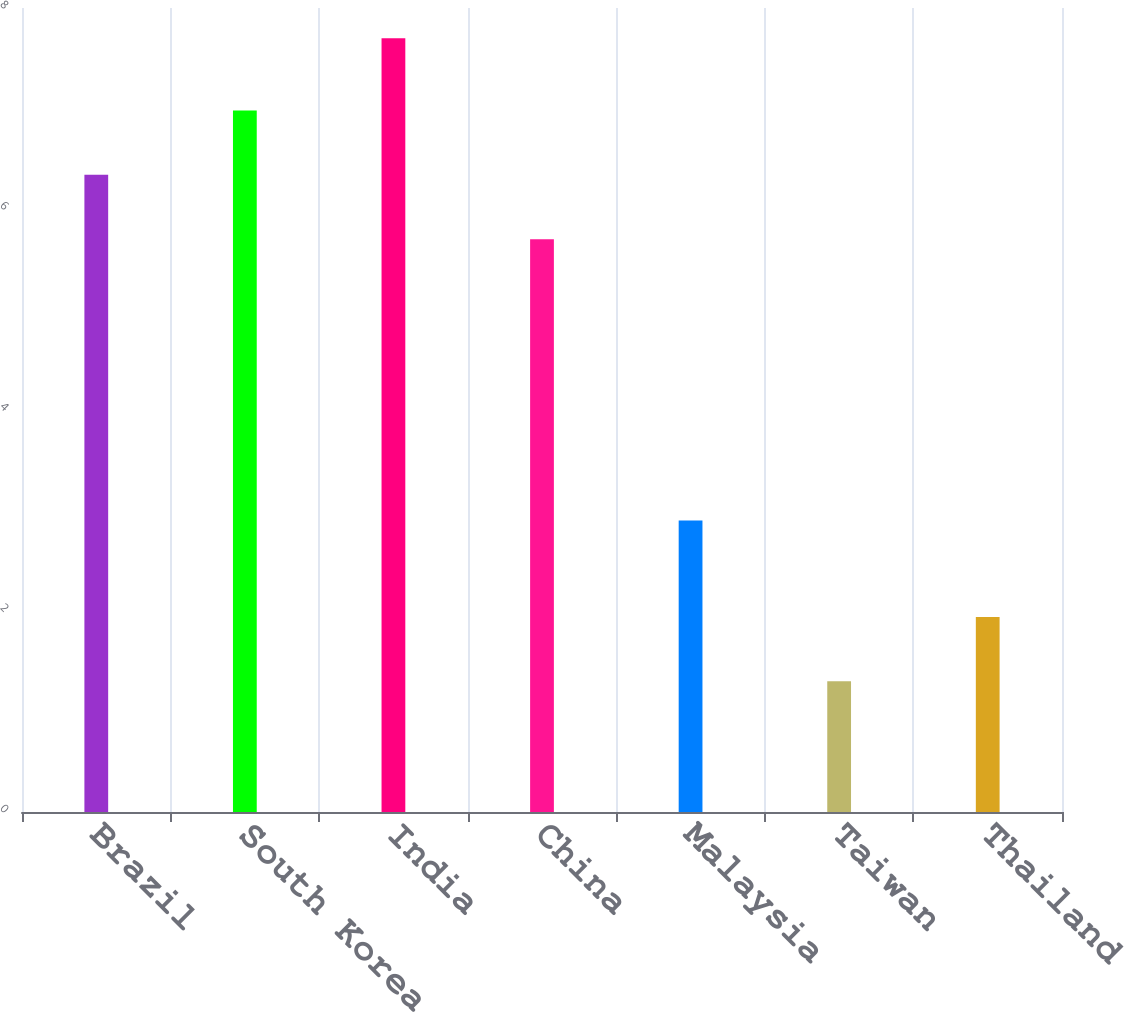Convert chart to OTSL. <chart><loc_0><loc_0><loc_500><loc_500><bar_chart><fcel>Brazil<fcel>South Korea<fcel>India<fcel>China<fcel>Malaysia<fcel>Taiwan<fcel>Thailand<nl><fcel>6.34<fcel>6.98<fcel>7.7<fcel>5.7<fcel>2.9<fcel>1.3<fcel>1.94<nl></chart> 